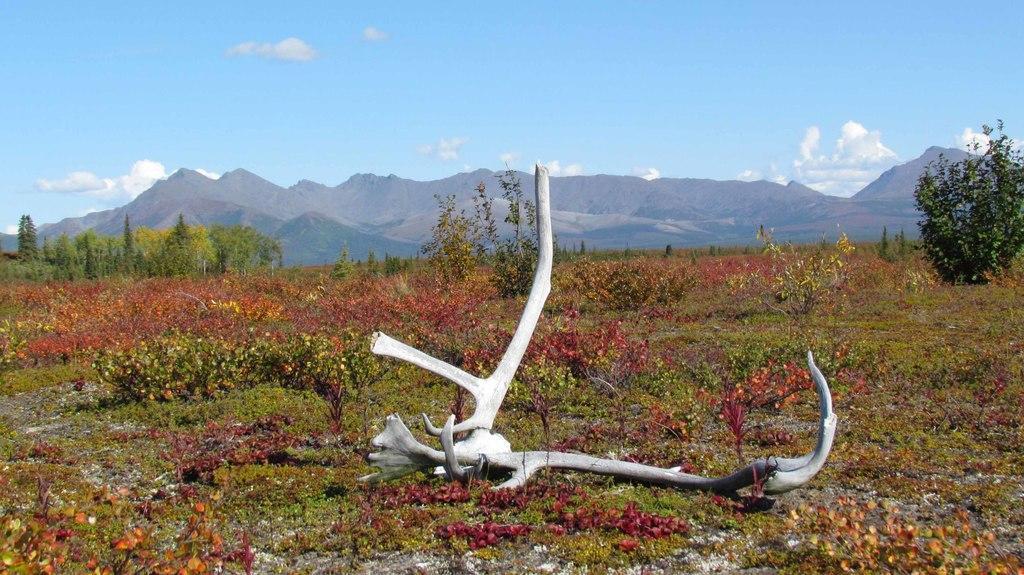Describe this image in one or two sentences. In this image there are few bones on the land having few plants and trees. Behind there are few hills. Top of image there is sky. 